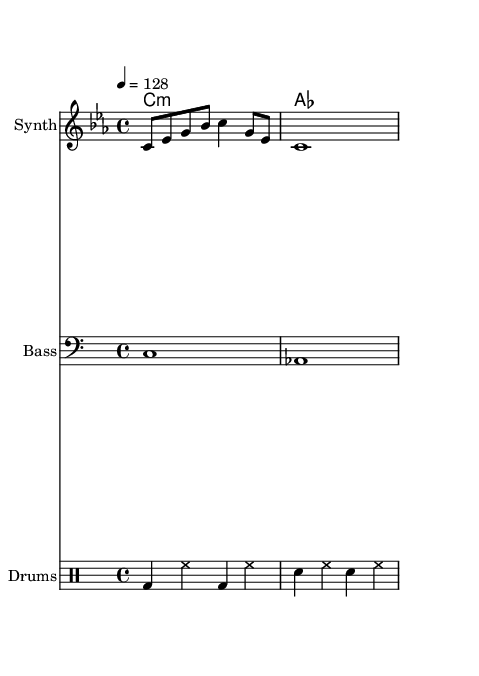What is the key signature of this music? The key signature is C minor, which has three flats: B flat, E flat, and A flat. This is indicated at the beginning of the staff.
Answer: C minor What is the time signature of this music? The time signature shown at the beginning indicates that it is 4/4, meaning there are four beats per measure and the quarter note gets one beat.
Answer: 4/4 What is the tempo of this piece? The tempo marking at the beginning states "4 = 128," meaning there are 128 beats per minute, indicating a moderately fast tempo.
Answer: 128 What instrument is specified for the melody? The score indicates the instrument for the melody staff is labeled as "Synth," suggesting that a synthesizer is intended to play the melody.
Answer: Synth What is the rhythmic pattern of the drums? By analyzing the drum staff, the rhythmic pattern starts with a bass drum on beats 1 and 3, followed by a snare on beats 2 and 4, typical in House music.
Answer: bd, sn How many measures are shown for the melody? The melody part consists of two measures, as indicated by the placement of bar lines in the sheet music, one measure for the first line and one for the second.
Answer: 2 What lyrical theme is expressed in the text? The text refers to "encrypted clues in the blockchain maze," suggesting a connection between the music's theme and cryptic elements often found in detective stories.
Answer: Encrypted clues 